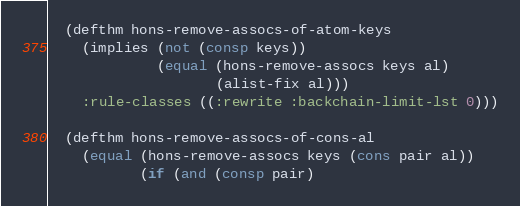Convert code to text. <code><loc_0><loc_0><loc_500><loc_500><_Lisp_>  (defthm hons-remove-assocs-of-atom-keys
    (implies (not (consp keys))
             (equal (hons-remove-assocs keys al)
                    (alist-fix al)))
    :rule-classes ((:rewrite :backchain-limit-lst 0)))

  (defthm hons-remove-assocs-of-cons-al
    (equal (hons-remove-assocs keys (cons pair al))
           (if (and (consp pair)</code> 